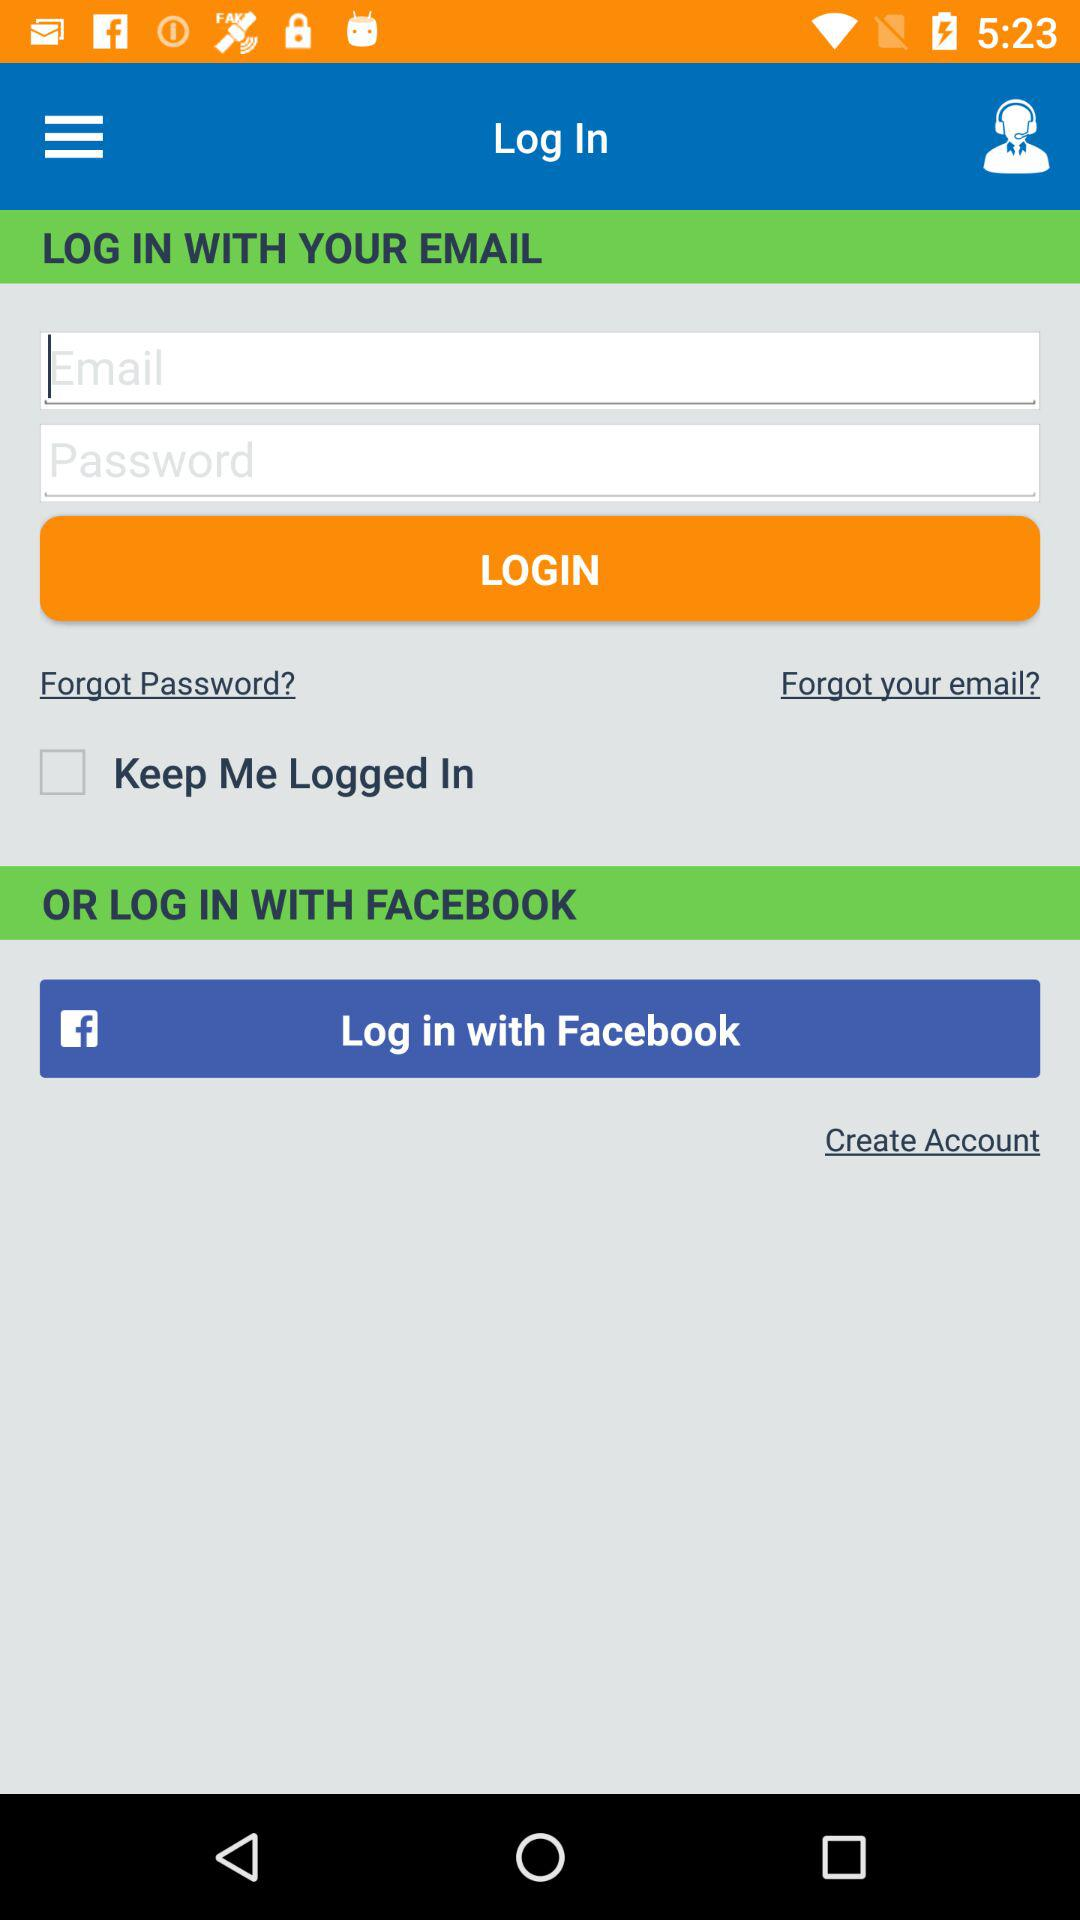How many input fields are required to log in?
Answer the question using a single word or phrase. 2 